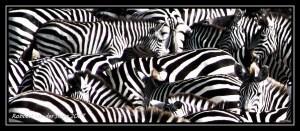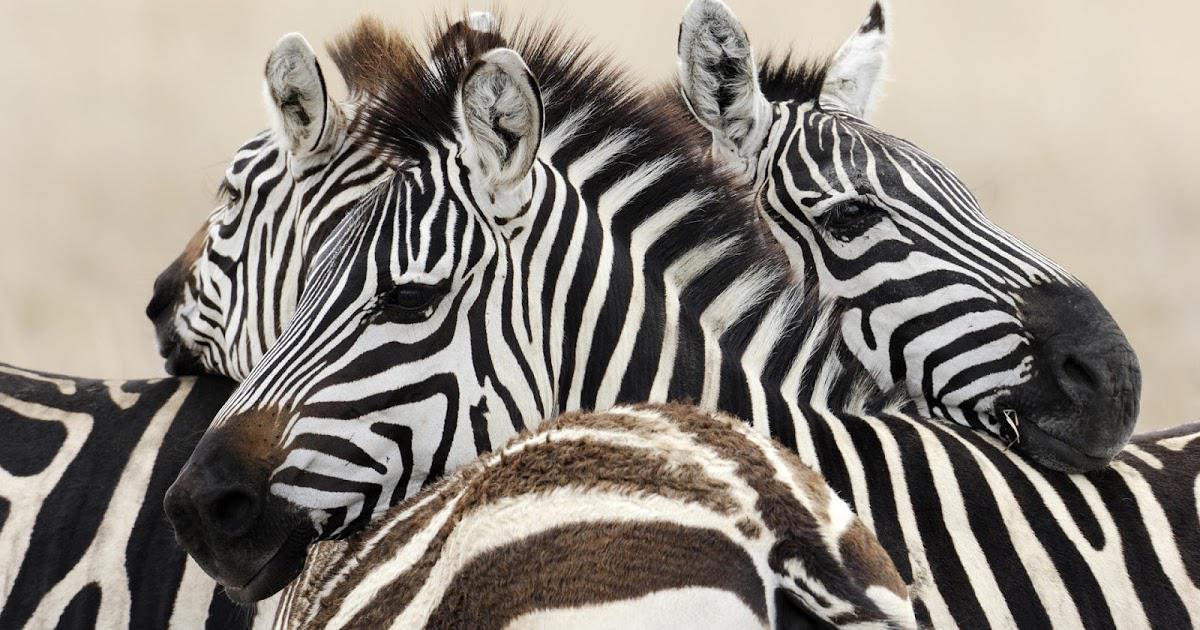The first image is the image on the left, the second image is the image on the right. For the images displayed, is the sentence "In at least one image there are at least 8 zebra standing in tall grass." factually correct? Answer yes or no. No. The first image is the image on the left, the second image is the image on the right. Evaluate the accuracy of this statement regarding the images: "One image shows a mass of zebras with no visible space between or around them, and the other image shows a close grouping of zebras with space above them.". Is it true? Answer yes or no. Yes. 